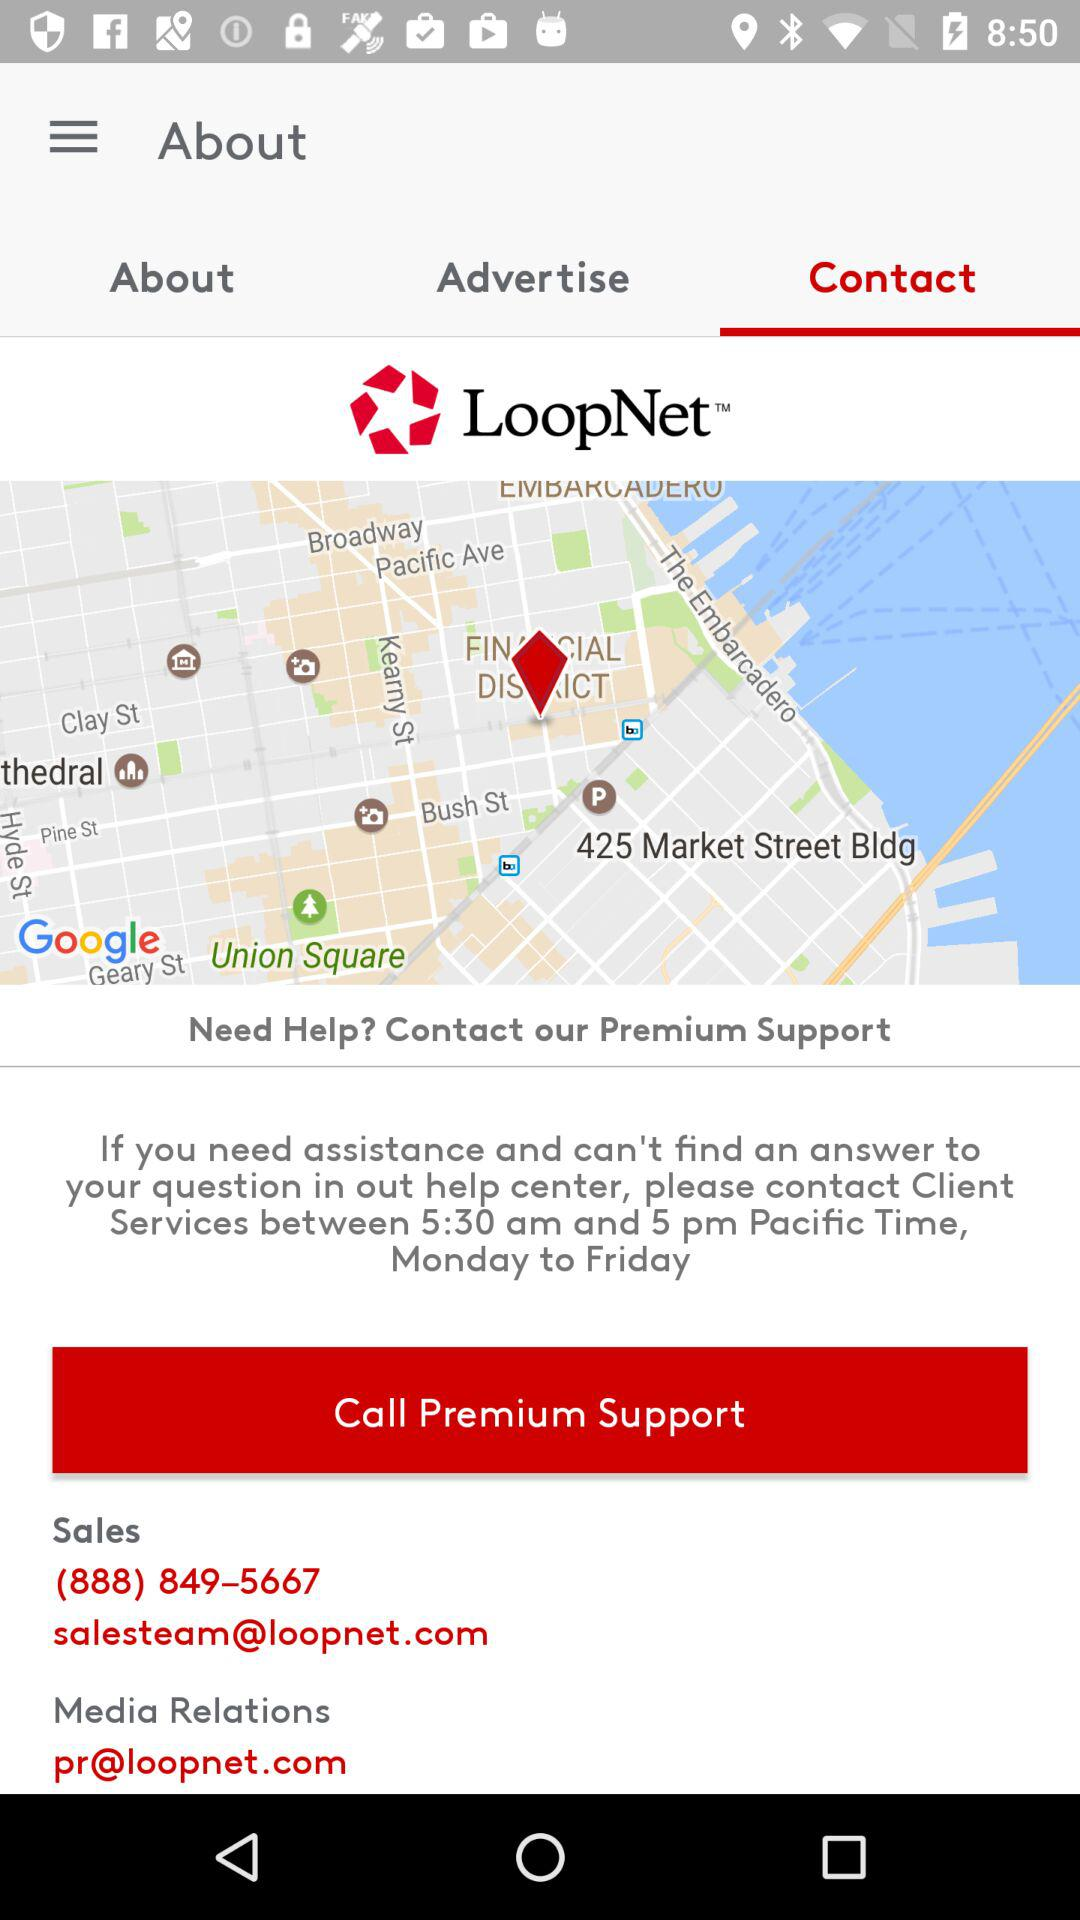What is the contact number for sales? The contact number is (888) 849–5667. 